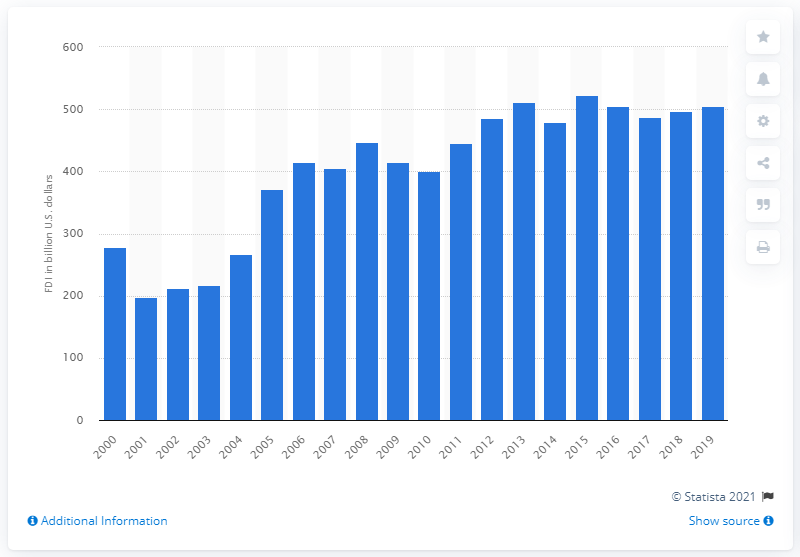Specify some key components in this picture. In 2019, the United Kingdom invested approximately 505.09 million dollars in the United States. 